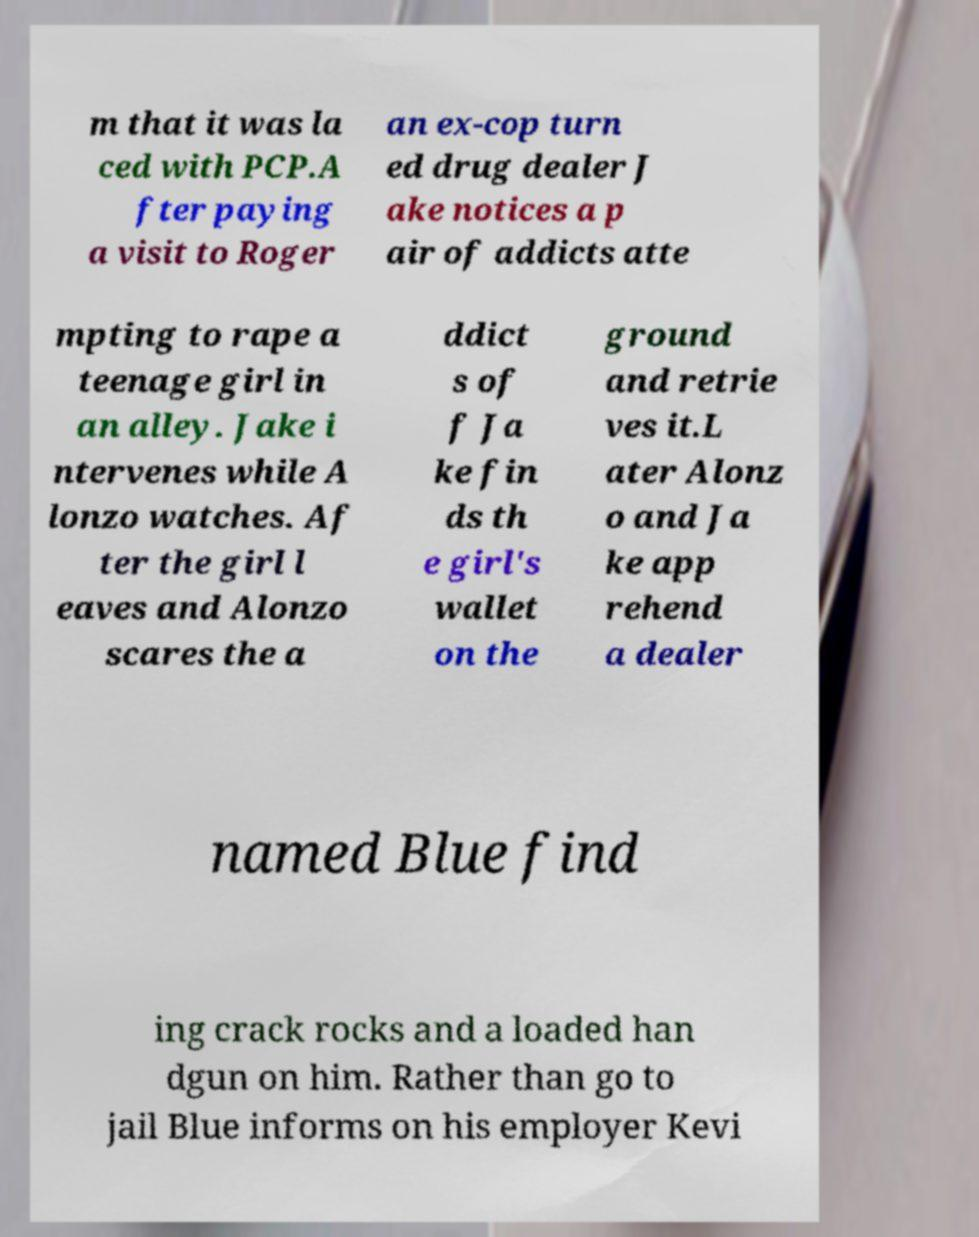Can you read and provide the text displayed in the image?This photo seems to have some interesting text. Can you extract and type it out for me? m that it was la ced with PCP.A fter paying a visit to Roger an ex-cop turn ed drug dealer J ake notices a p air of addicts atte mpting to rape a teenage girl in an alley. Jake i ntervenes while A lonzo watches. Af ter the girl l eaves and Alonzo scares the a ddict s of f Ja ke fin ds th e girl's wallet on the ground and retrie ves it.L ater Alonz o and Ja ke app rehend a dealer named Blue find ing crack rocks and a loaded han dgun on him. Rather than go to jail Blue informs on his employer Kevi 